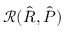<formula> <loc_0><loc_0><loc_500><loc_500>\mathcal { R } ( \hat { R } , \hat { P } )</formula> 